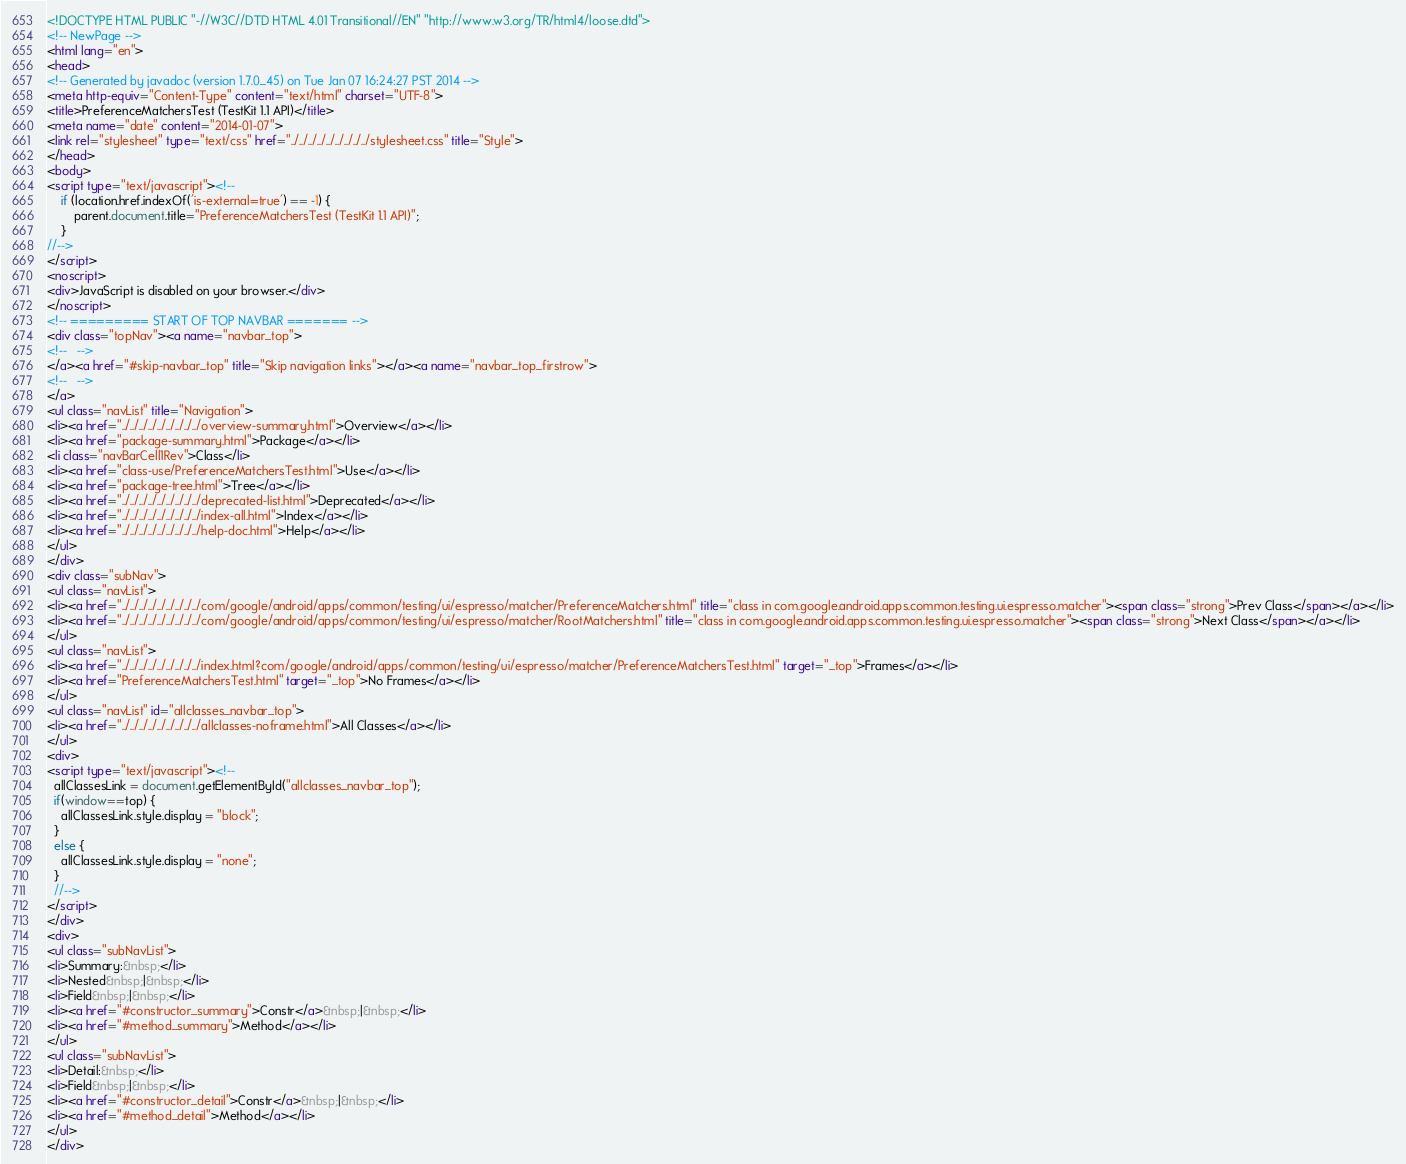<code> <loc_0><loc_0><loc_500><loc_500><_HTML_><!DOCTYPE HTML PUBLIC "-//W3C//DTD HTML 4.01 Transitional//EN" "http://www.w3.org/TR/html4/loose.dtd">
<!-- NewPage -->
<html lang="en">
<head>
<!-- Generated by javadoc (version 1.7.0_45) on Tue Jan 07 16:24:27 PST 2014 -->
<meta http-equiv="Content-Type" content="text/html" charset="UTF-8">
<title>PreferenceMatchersTest (TestKit 1.1 API)</title>
<meta name="date" content="2014-01-07">
<link rel="stylesheet" type="text/css" href="../../../../../../../../../stylesheet.css" title="Style">
</head>
<body>
<script type="text/javascript"><!--
    if (location.href.indexOf('is-external=true') == -1) {
        parent.document.title="PreferenceMatchersTest (TestKit 1.1 API)";
    }
//-->
</script>
<noscript>
<div>JavaScript is disabled on your browser.</div>
</noscript>
<!-- ========= START OF TOP NAVBAR ======= -->
<div class="topNav"><a name="navbar_top">
<!--   -->
</a><a href="#skip-navbar_top" title="Skip navigation links"></a><a name="navbar_top_firstrow">
<!--   -->
</a>
<ul class="navList" title="Navigation">
<li><a href="../../../../../../../../../overview-summary.html">Overview</a></li>
<li><a href="package-summary.html">Package</a></li>
<li class="navBarCell1Rev">Class</li>
<li><a href="class-use/PreferenceMatchersTest.html">Use</a></li>
<li><a href="package-tree.html">Tree</a></li>
<li><a href="../../../../../../../../../deprecated-list.html">Deprecated</a></li>
<li><a href="../../../../../../../../../index-all.html">Index</a></li>
<li><a href="../../../../../../../../../help-doc.html">Help</a></li>
</ul>
</div>
<div class="subNav">
<ul class="navList">
<li><a href="../../../../../../../../../com/google/android/apps/common/testing/ui/espresso/matcher/PreferenceMatchers.html" title="class in com.google.android.apps.common.testing.ui.espresso.matcher"><span class="strong">Prev Class</span></a></li>
<li><a href="../../../../../../../../../com/google/android/apps/common/testing/ui/espresso/matcher/RootMatchers.html" title="class in com.google.android.apps.common.testing.ui.espresso.matcher"><span class="strong">Next Class</span></a></li>
</ul>
<ul class="navList">
<li><a href="../../../../../../../../../index.html?com/google/android/apps/common/testing/ui/espresso/matcher/PreferenceMatchersTest.html" target="_top">Frames</a></li>
<li><a href="PreferenceMatchersTest.html" target="_top">No Frames</a></li>
</ul>
<ul class="navList" id="allclasses_navbar_top">
<li><a href="../../../../../../../../../allclasses-noframe.html">All Classes</a></li>
</ul>
<div>
<script type="text/javascript"><!--
  allClassesLink = document.getElementById("allclasses_navbar_top");
  if(window==top) {
    allClassesLink.style.display = "block";
  }
  else {
    allClassesLink.style.display = "none";
  }
  //-->
</script>
</div>
<div>
<ul class="subNavList">
<li>Summary:&nbsp;</li>
<li>Nested&nbsp;|&nbsp;</li>
<li>Field&nbsp;|&nbsp;</li>
<li><a href="#constructor_summary">Constr</a>&nbsp;|&nbsp;</li>
<li><a href="#method_summary">Method</a></li>
</ul>
<ul class="subNavList">
<li>Detail:&nbsp;</li>
<li>Field&nbsp;|&nbsp;</li>
<li><a href="#constructor_detail">Constr</a>&nbsp;|&nbsp;</li>
<li><a href="#method_detail">Method</a></li>
</ul>
</div></code> 